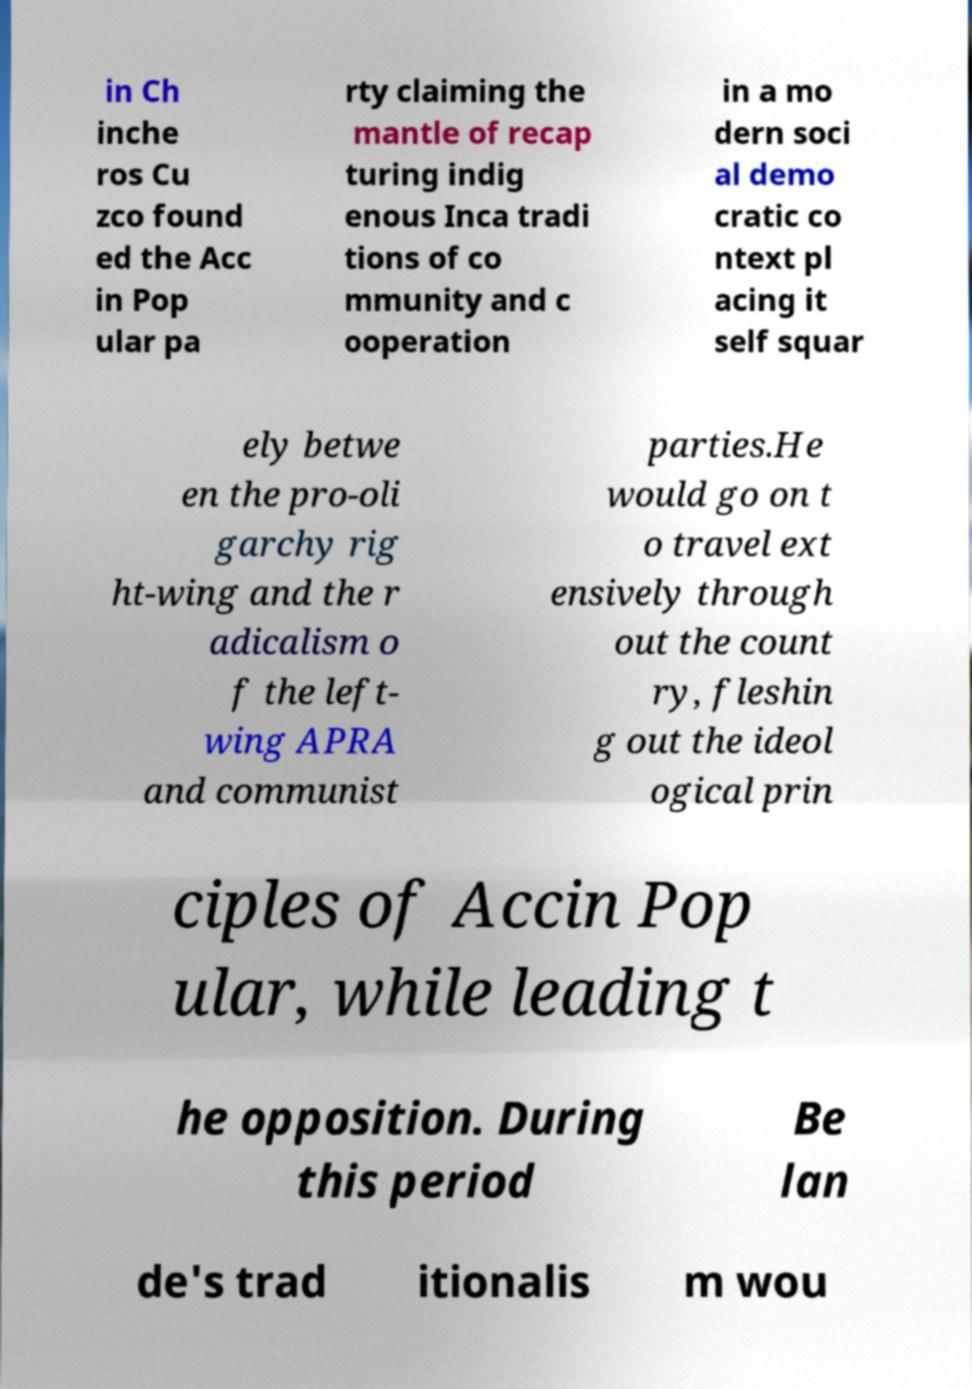Can you accurately transcribe the text from the provided image for me? in Ch inche ros Cu zco found ed the Acc in Pop ular pa rty claiming the mantle of recap turing indig enous Inca tradi tions of co mmunity and c ooperation in a mo dern soci al demo cratic co ntext pl acing it self squar ely betwe en the pro-oli garchy rig ht-wing and the r adicalism o f the left- wing APRA and communist parties.He would go on t o travel ext ensively through out the count ry, fleshin g out the ideol ogical prin ciples of Accin Pop ular, while leading t he opposition. During this period Be lan de's trad itionalis m wou 